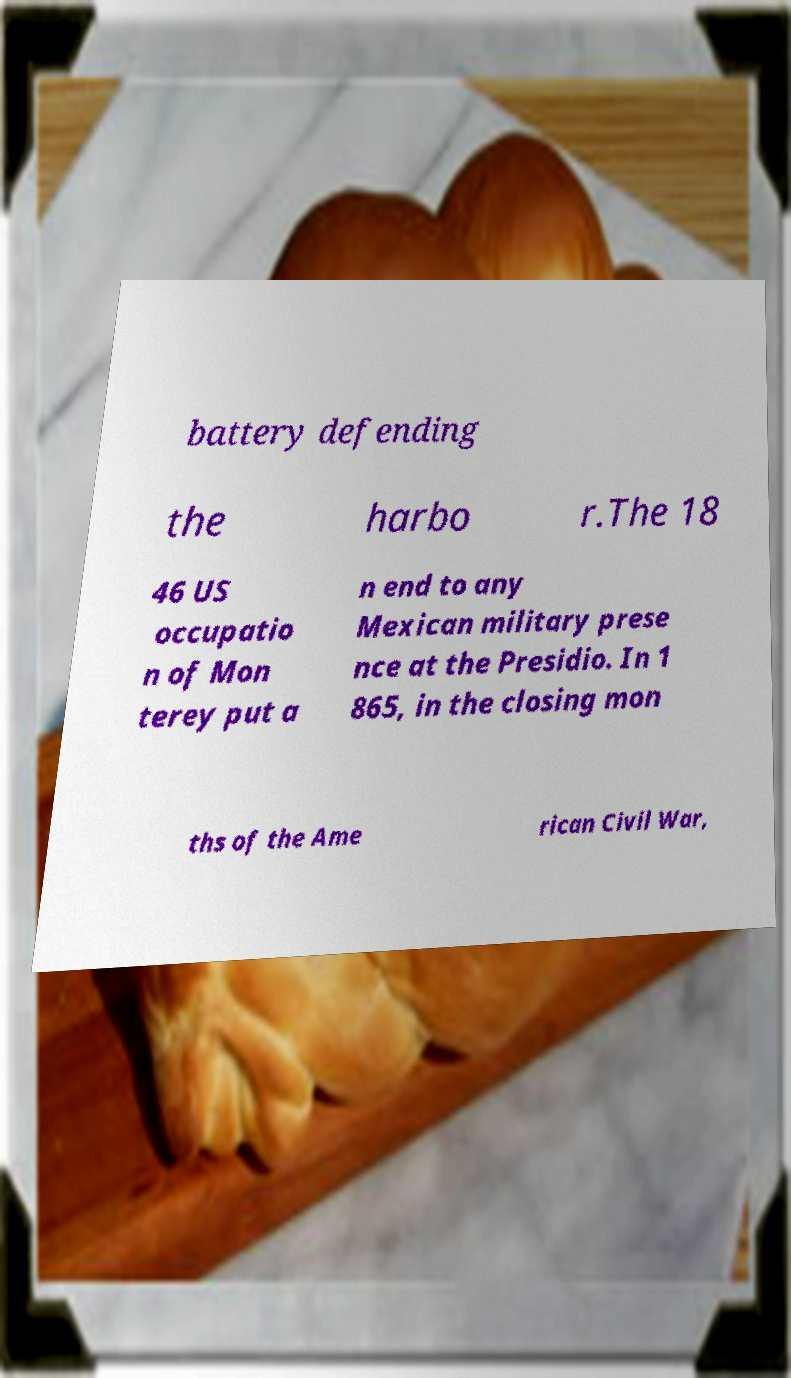I need the written content from this picture converted into text. Can you do that? battery defending the harbo r.The 18 46 US occupatio n of Mon terey put a n end to any Mexican military prese nce at the Presidio. In 1 865, in the closing mon ths of the Ame rican Civil War, 